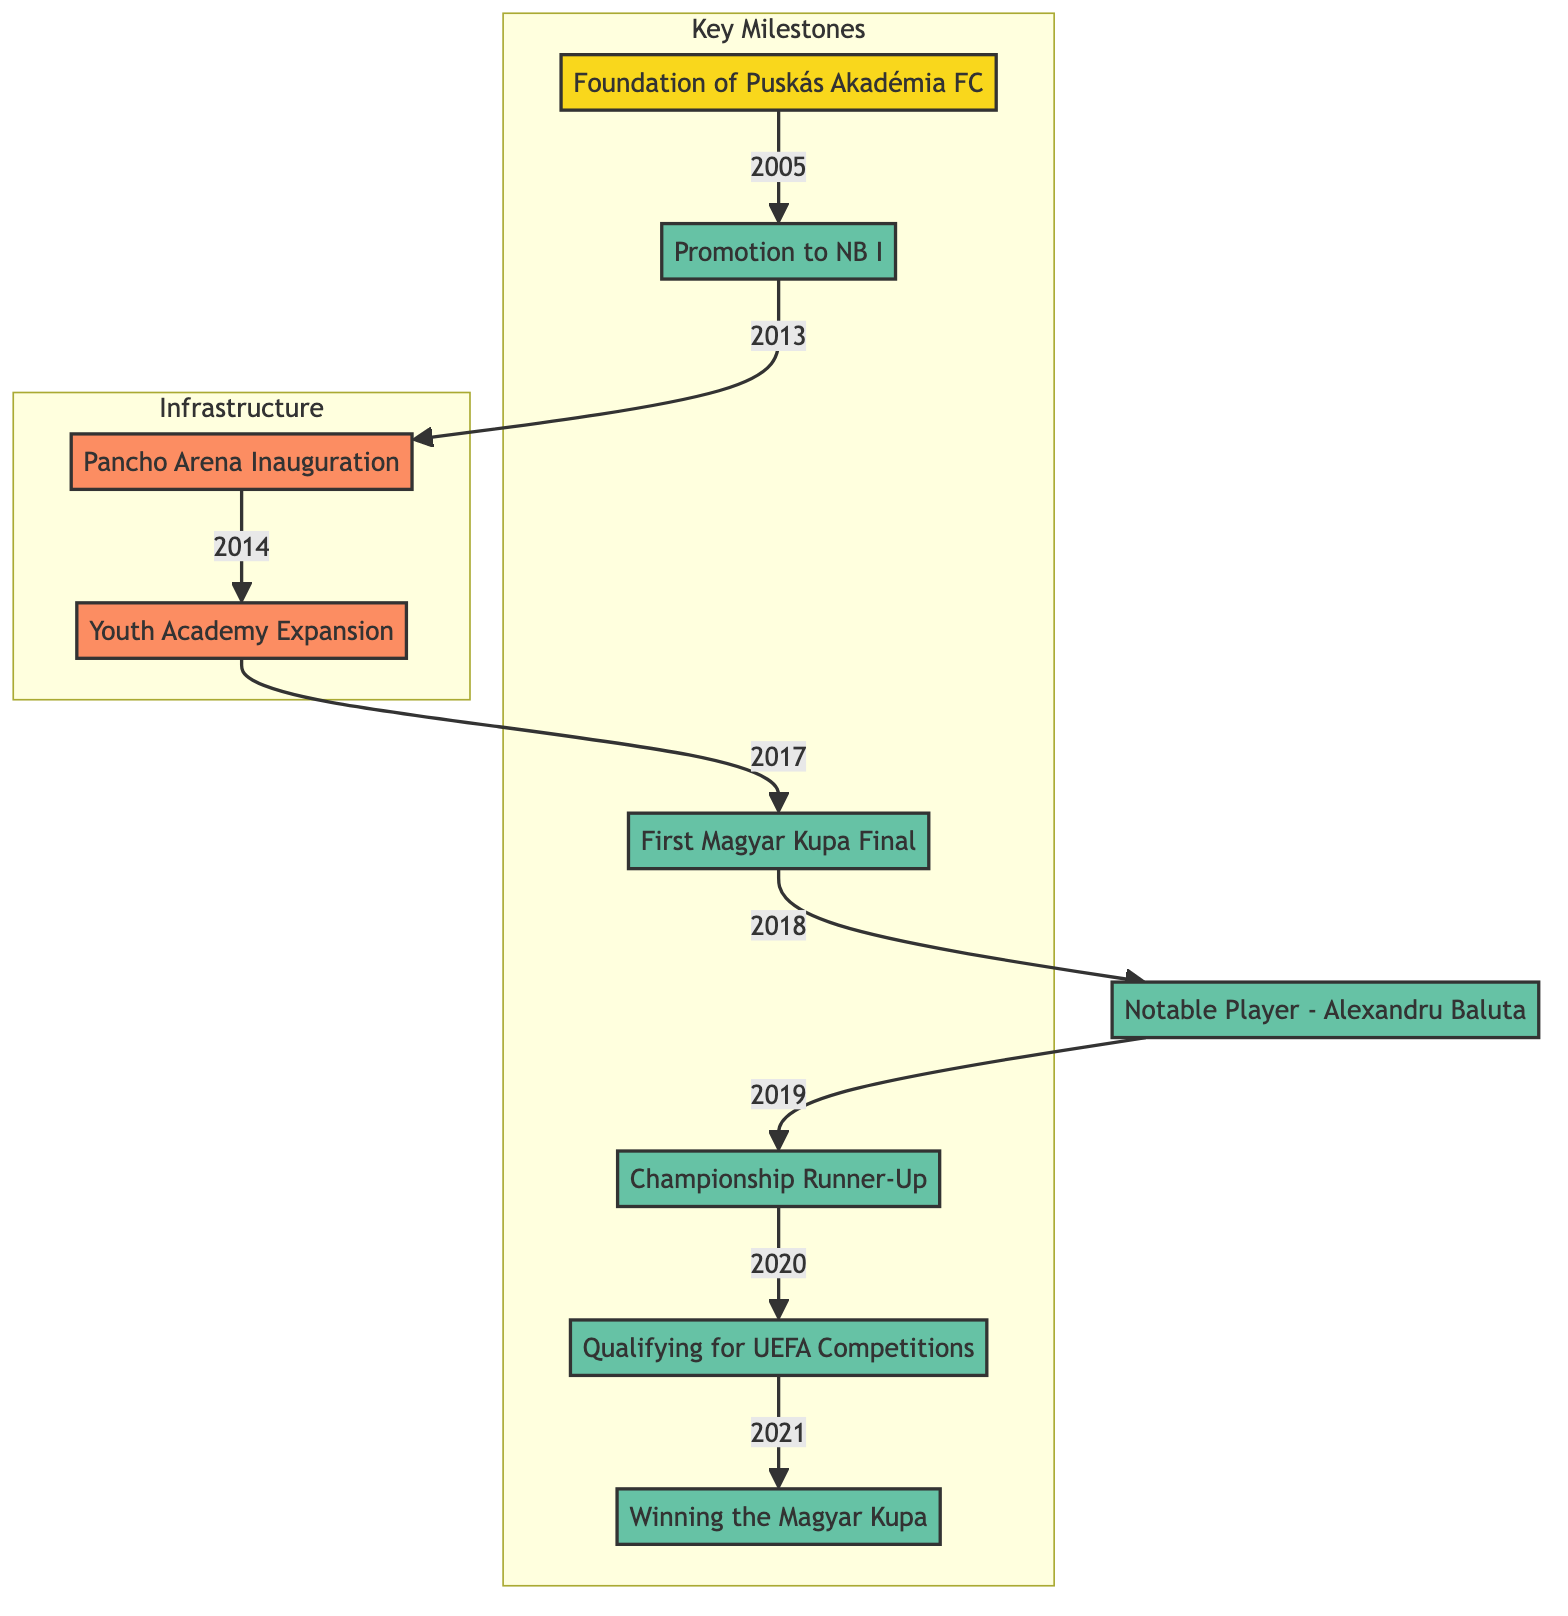What year was Puskás Akadémia FC founded? The diagram shows the milestone "Foundation of Puskás Akadémia FC" connected to the year 2005.
Answer: 2005 What significant milestone occurred in 2014? In 2014, the diagram indicates the milestone "Pancho Arena Inauguration."
Answer: Pancho Arena Inauguration How many milestones are categorized as achievements in the diagram? Counting the nodes in the "Key Milestones" subgraph, we find six achievements listed.
Answer: 6 Which notable player joined Puskás Akadémia FC in 2019? The diagram states "Notable Player - Alexandru Baluta" under the 2019 milestone.
Answer: Alexandru Baluta What was Puskás Akadémia FC's best league finish according to the diagram? The diagram indicates that in 2020 the club finished as "Championship Runner-Up."
Answer: Championship Runner-Up What is the relationship between the inauguration of the Pancho Arena and the youth academy expansion? The diagrams show that the "Youth Academy Expansion" is a direct successor to the "Pancho Arena Inauguration," occurring in 2017 after the 2014 milestone.
Answer: Youth Academy Expansion follows Pancho Arena Inauguration In which year did Puskás Akadémia FC qualify for UEFA competitions? Looking at the nodes and their connections, we see that the qualification happened in 2021.
Answer: 2021 What type of developments are classified under the infrastructure category? The diagram defines "Pancho Arena Inauguration" and "Youth Academy Expansion" as infrastructure developments.
Answer: Pancho Arena Inauguration and Youth Academy Expansion Which milestone marks the club's first trophy victory? The diagram highlights that winning the Magyar Kupa in 2022 signifies the first trophy for the club.
Answer: Winning the Magyar Kupa 